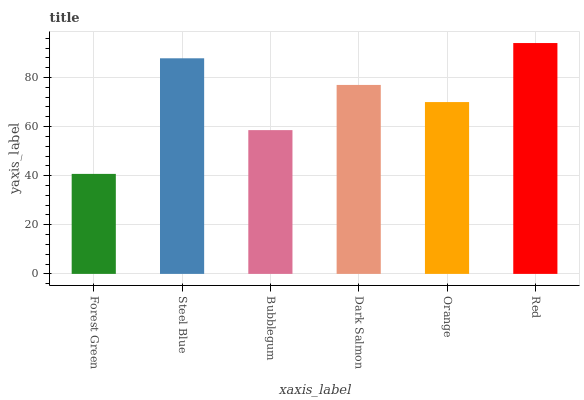Is Steel Blue the minimum?
Answer yes or no. No. Is Steel Blue the maximum?
Answer yes or no. No. Is Steel Blue greater than Forest Green?
Answer yes or no. Yes. Is Forest Green less than Steel Blue?
Answer yes or no. Yes. Is Forest Green greater than Steel Blue?
Answer yes or no. No. Is Steel Blue less than Forest Green?
Answer yes or no. No. Is Dark Salmon the high median?
Answer yes or no. Yes. Is Orange the low median?
Answer yes or no. Yes. Is Red the high median?
Answer yes or no. No. Is Steel Blue the low median?
Answer yes or no. No. 